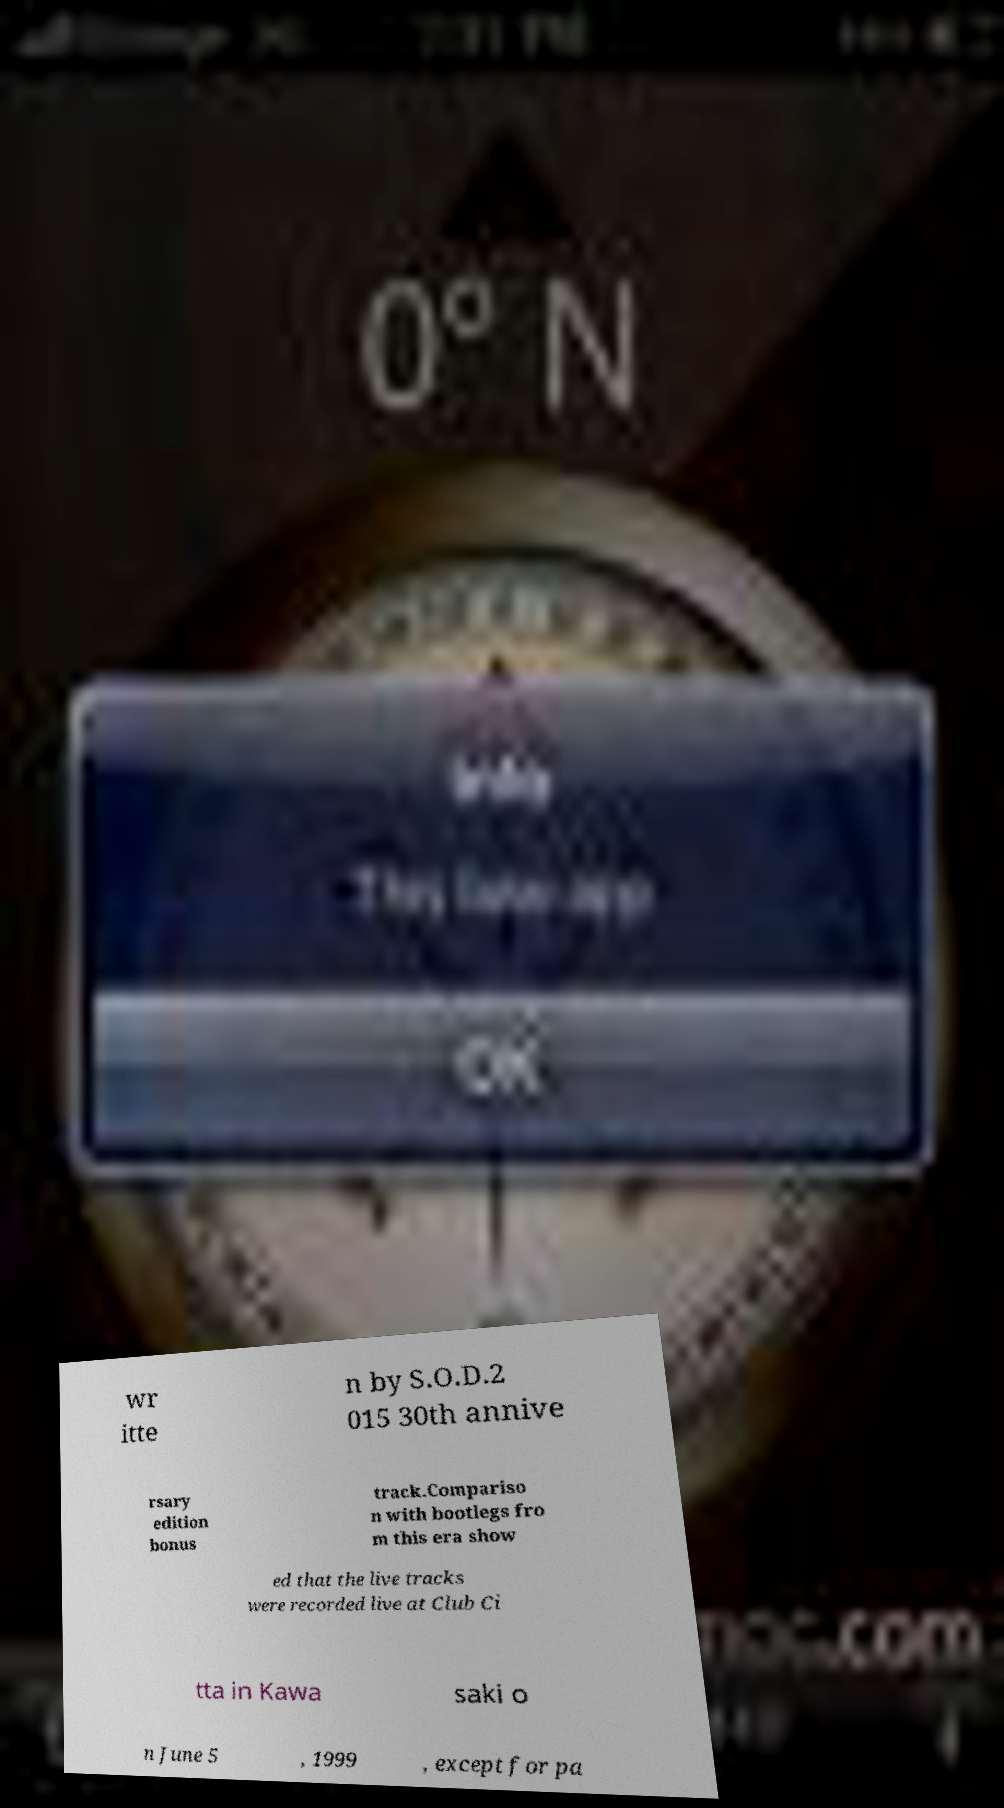There's text embedded in this image that I need extracted. Can you transcribe it verbatim? wr itte n by S.O.D.2 015 30th annive rsary edition bonus track.Compariso n with bootlegs fro m this era show ed that the live tracks were recorded live at Club Ci tta in Kawa saki o n June 5 , 1999 , except for pa 